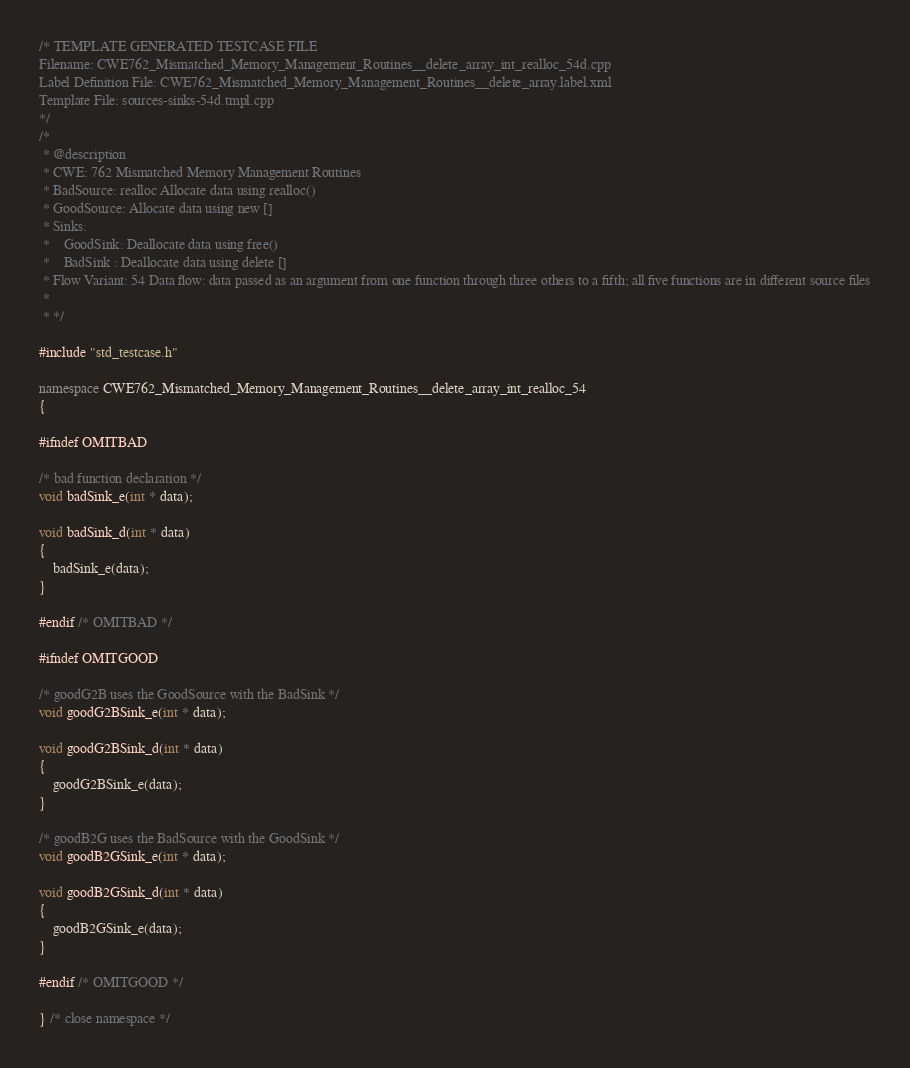<code> <loc_0><loc_0><loc_500><loc_500><_C++_>/* TEMPLATE GENERATED TESTCASE FILE
Filename: CWE762_Mismatched_Memory_Management_Routines__delete_array_int_realloc_54d.cpp
Label Definition File: CWE762_Mismatched_Memory_Management_Routines__delete_array.label.xml
Template File: sources-sinks-54d.tmpl.cpp
*/
/*
 * @description
 * CWE: 762 Mismatched Memory Management Routines
 * BadSource: realloc Allocate data using realloc()
 * GoodSource: Allocate data using new []
 * Sinks:
 *    GoodSink: Deallocate data using free()
 *    BadSink : Deallocate data using delete []
 * Flow Variant: 54 Data flow: data passed as an argument from one function through three others to a fifth; all five functions are in different source files
 *
 * */

#include "std_testcase.h"

namespace CWE762_Mismatched_Memory_Management_Routines__delete_array_int_realloc_54
{

#ifndef OMITBAD

/* bad function declaration */
void badSink_e(int * data);

void badSink_d(int * data)
{
    badSink_e(data);
}

#endif /* OMITBAD */

#ifndef OMITGOOD

/* goodG2B uses the GoodSource with the BadSink */
void goodG2BSink_e(int * data);

void goodG2BSink_d(int * data)
{
    goodG2BSink_e(data);
}

/* goodB2G uses the BadSource with the GoodSink */
void goodB2GSink_e(int * data);

void goodB2GSink_d(int * data)
{
    goodB2GSink_e(data);
}

#endif /* OMITGOOD */

} /* close namespace */
</code> 